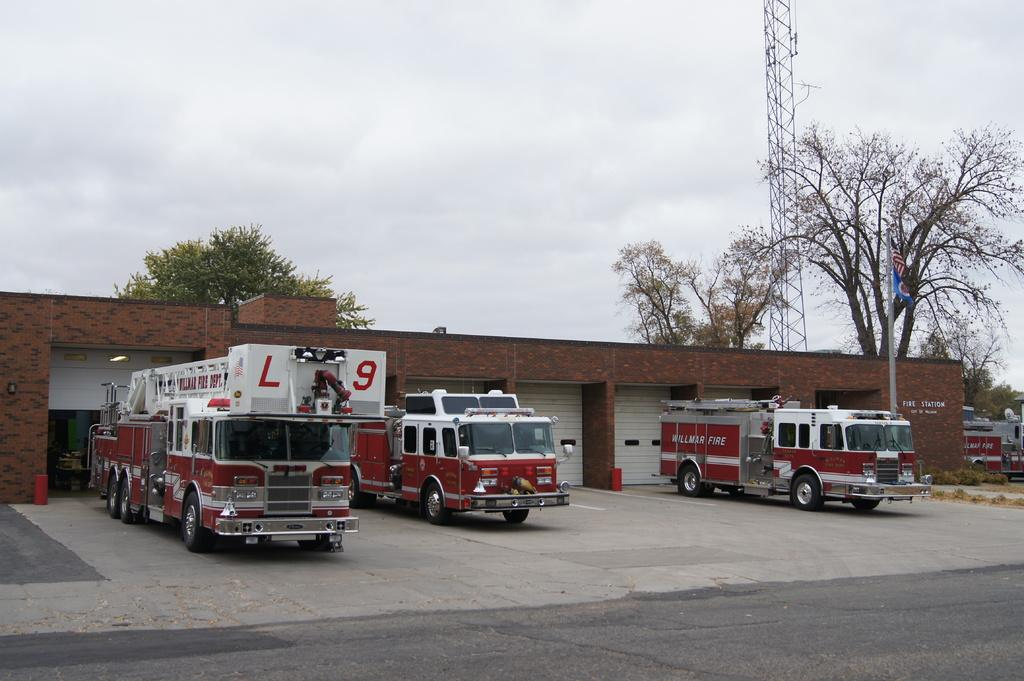What is the main feature of the image? There is a road in the image. What type of structures can be seen along the road? There are shutters in the image. What is present on the ground in the image? There are vehicles on the ground in the image. What type of vegetation is visible in the image? There are trees in the image. What is the tall, vertical object in the image? There is a pole in the image. What is attached to the pole? There is a flag in the image. What can be seen in the background of the image? The sky is visible in the background of the image, and there are clouds in the sky. What type of sound can be heard coming from the lace in the image? There is no lace present in the image, so it is not possible to determine what sound might be heard. 